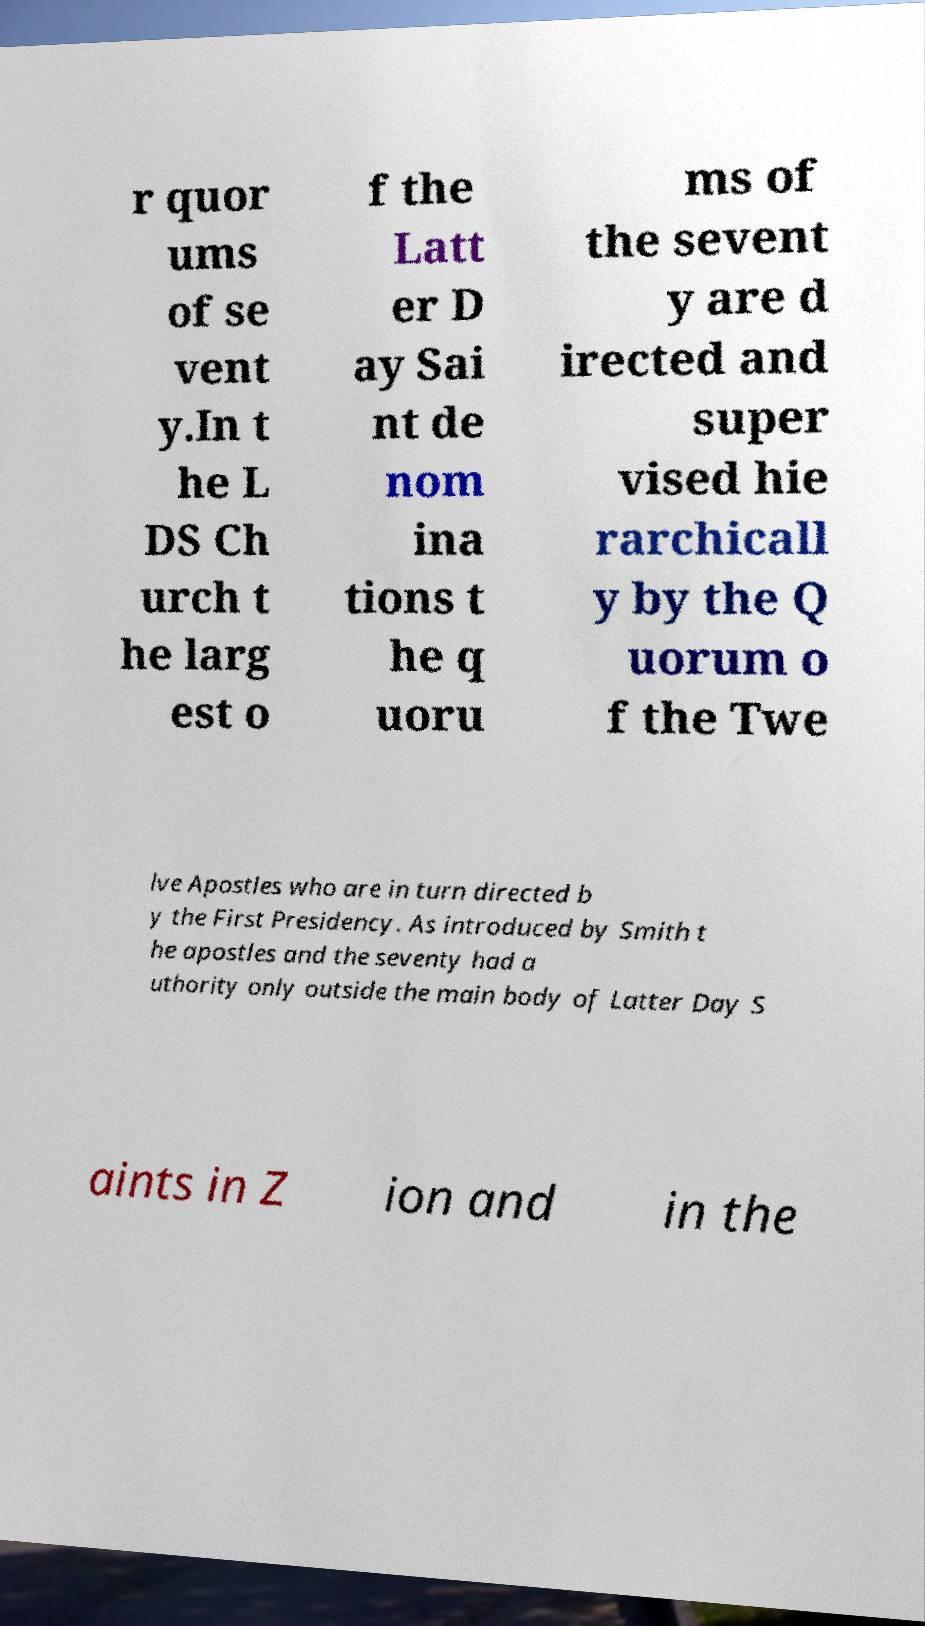There's text embedded in this image that I need extracted. Can you transcribe it verbatim? r quor ums of se vent y.In t he L DS Ch urch t he larg est o f the Latt er D ay Sai nt de nom ina tions t he q uoru ms of the sevent y are d irected and super vised hie rarchicall y by the Q uorum o f the Twe lve Apostles who are in turn directed b y the First Presidency. As introduced by Smith t he apostles and the seventy had a uthority only outside the main body of Latter Day S aints in Z ion and in the 